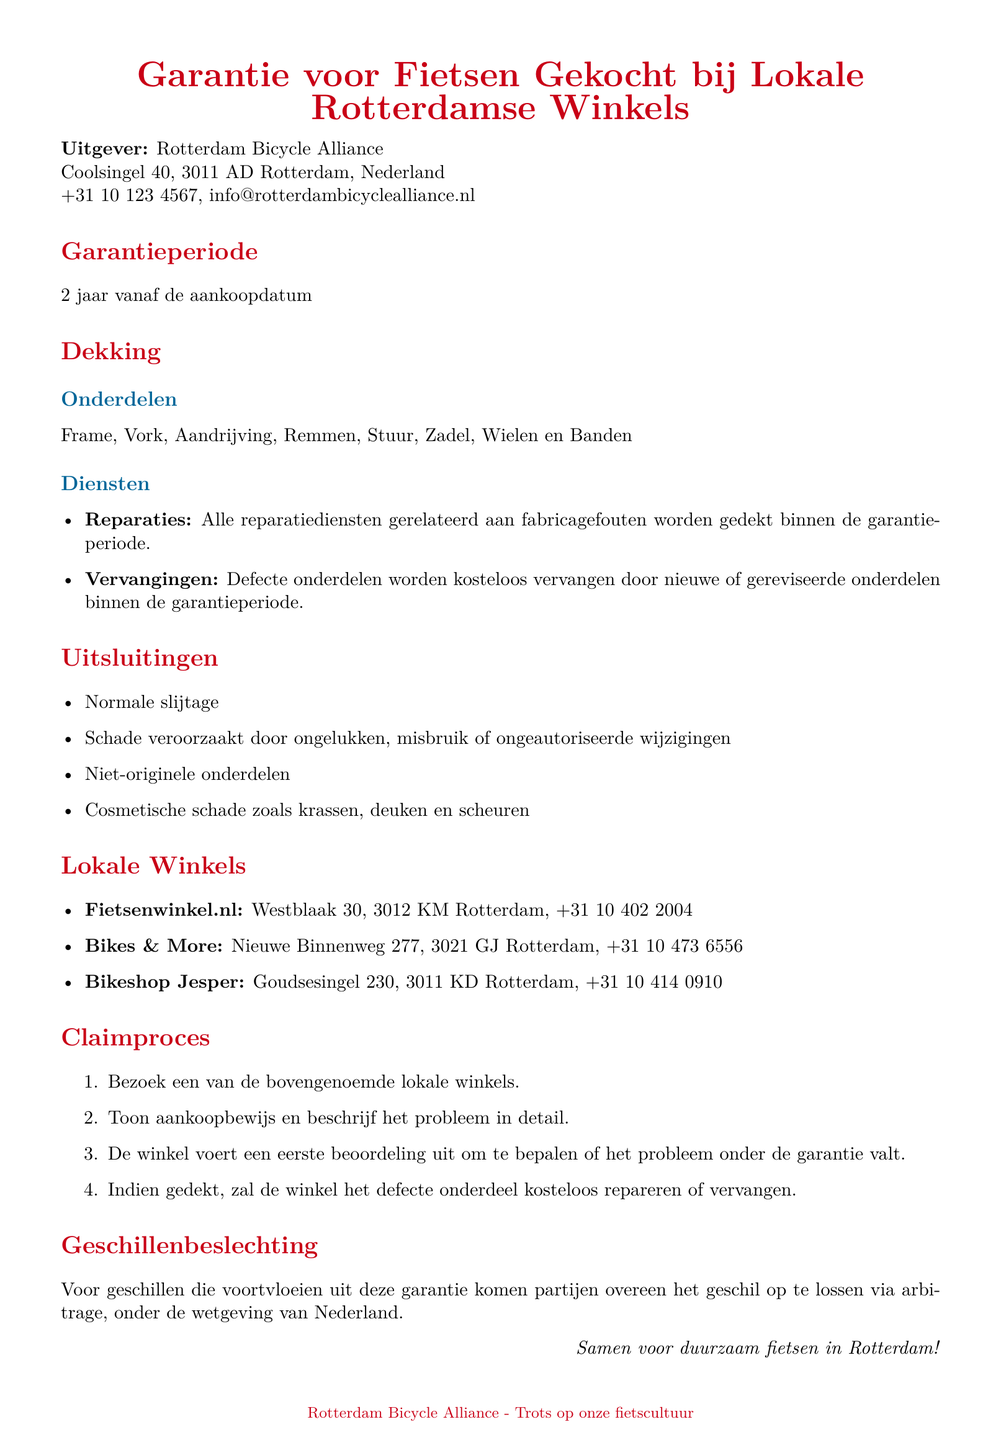Wat is de garantieperiode? De garantieperiode is vastgesteld op 2 jaar vanaf de aankoopdatum.
Answer: 2 jaar Welke onderdelen zijn gedekt onder de garantie? De gedekte onderdelen omvatten Frame, Vork, Aandrijving, Remmen, Stuur, Zadel, Wielen en Banden.
Answer: Frame, Vork, Aandrijving, Remmen, Stuur, Zadel, Wielen en Banden Wat moet ik tonen om een claim in te dienen? Om een claim in te dienen, moet je het aankoopbewijs tonen aan de winkel.
Answer: Aankoopbewijs Wat gebeurt er bij schade door ongelukken? Schade veroorzaakt door ongelukken valt niet onder de garantie en is uitgesloten.
Answer: Uitsluiting Hoeveel lokale winkels zijn er vermeld? Er worden drie lokale winkels genoemd waar fietsen gekocht kunnen worden.
Answer: Drie Wat is het eerste stap van het claimproces? Het eerste stap is om een van de bovengenoemde lokale winkels te bezoeken.
Answer: Bezoek een lokale winkel Wat is de contactinformatie van Fietsenwinkel.nl? De contactinformatie van Fietsenwinkel.nl is Westblaak 30, 3012 KM Rotterdam, +31 10 402 2004.
Answer: Westblaak 30, 3012 KM Rotterdam, +31 10 402 2004 Waar worden geschillen opgelost? Geschillen worden opgelost via arbitrage onder de wetgeving van Nederland.
Answer: Via arbitrage Nederland 